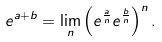<formula> <loc_0><loc_0><loc_500><loc_500>e ^ { a + b } = \lim _ { n } \left ( e ^ { \frac { a } { n } } e ^ { \frac { b } { n } } \right ) ^ { n } .</formula> 